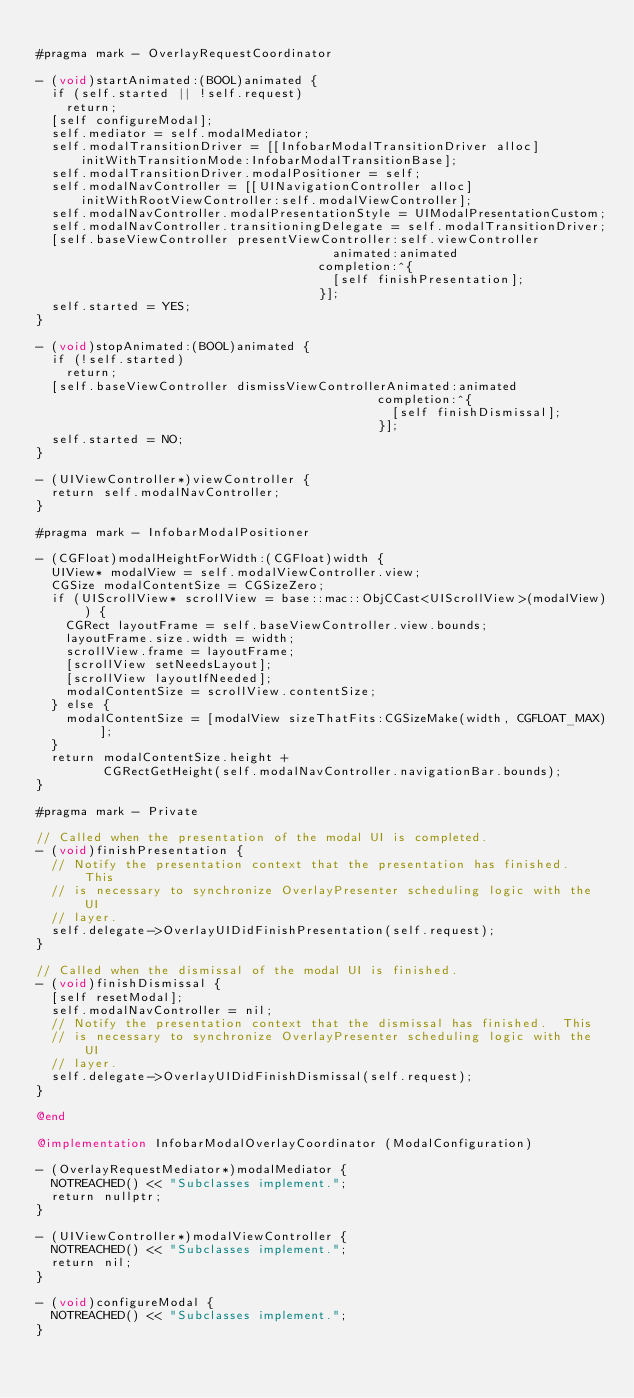Convert code to text. <code><loc_0><loc_0><loc_500><loc_500><_ObjectiveC_>
#pragma mark - OverlayRequestCoordinator

- (void)startAnimated:(BOOL)animated {
  if (self.started || !self.request)
    return;
  [self configureModal];
  self.mediator = self.modalMediator;
  self.modalTransitionDriver = [[InfobarModalTransitionDriver alloc]
      initWithTransitionMode:InfobarModalTransitionBase];
  self.modalTransitionDriver.modalPositioner = self;
  self.modalNavController = [[UINavigationController alloc]
      initWithRootViewController:self.modalViewController];
  self.modalNavController.modalPresentationStyle = UIModalPresentationCustom;
  self.modalNavController.transitioningDelegate = self.modalTransitionDriver;
  [self.baseViewController presentViewController:self.viewController
                                        animated:animated
                                      completion:^{
                                        [self finishPresentation];
                                      }];
  self.started = YES;
}

- (void)stopAnimated:(BOOL)animated {
  if (!self.started)
    return;
  [self.baseViewController dismissViewControllerAnimated:animated
                                              completion:^{
                                                [self finishDismissal];
                                              }];
  self.started = NO;
}

- (UIViewController*)viewController {
  return self.modalNavController;
}

#pragma mark - InfobarModalPositioner

- (CGFloat)modalHeightForWidth:(CGFloat)width {
  UIView* modalView = self.modalViewController.view;
  CGSize modalContentSize = CGSizeZero;
  if (UIScrollView* scrollView = base::mac::ObjCCast<UIScrollView>(modalView)) {
    CGRect layoutFrame = self.baseViewController.view.bounds;
    layoutFrame.size.width = width;
    scrollView.frame = layoutFrame;
    [scrollView setNeedsLayout];
    [scrollView layoutIfNeeded];
    modalContentSize = scrollView.contentSize;
  } else {
    modalContentSize = [modalView sizeThatFits:CGSizeMake(width, CGFLOAT_MAX)];
  }
  return modalContentSize.height +
         CGRectGetHeight(self.modalNavController.navigationBar.bounds);
}

#pragma mark - Private

// Called when the presentation of the modal UI is completed.
- (void)finishPresentation {
  // Notify the presentation context that the presentation has finished.  This
  // is necessary to synchronize OverlayPresenter scheduling logic with the UI
  // layer.
  self.delegate->OverlayUIDidFinishPresentation(self.request);
}

// Called when the dismissal of the modal UI is finished.
- (void)finishDismissal {
  [self resetModal];
  self.modalNavController = nil;
  // Notify the presentation context that the dismissal has finished.  This
  // is necessary to synchronize OverlayPresenter scheduling logic with the UI
  // layer.
  self.delegate->OverlayUIDidFinishDismissal(self.request);
}

@end

@implementation InfobarModalOverlayCoordinator (ModalConfiguration)

- (OverlayRequestMediator*)modalMediator {
  NOTREACHED() << "Subclasses implement.";
  return nullptr;
}

- (UIViewController*)modalViewController {
  NOTREACHED() << "Subclasses implement.";
  return nil;
}

- (void)configureModal {
  NOTREACHED() << "Subclasses implement.";
}
</code> 